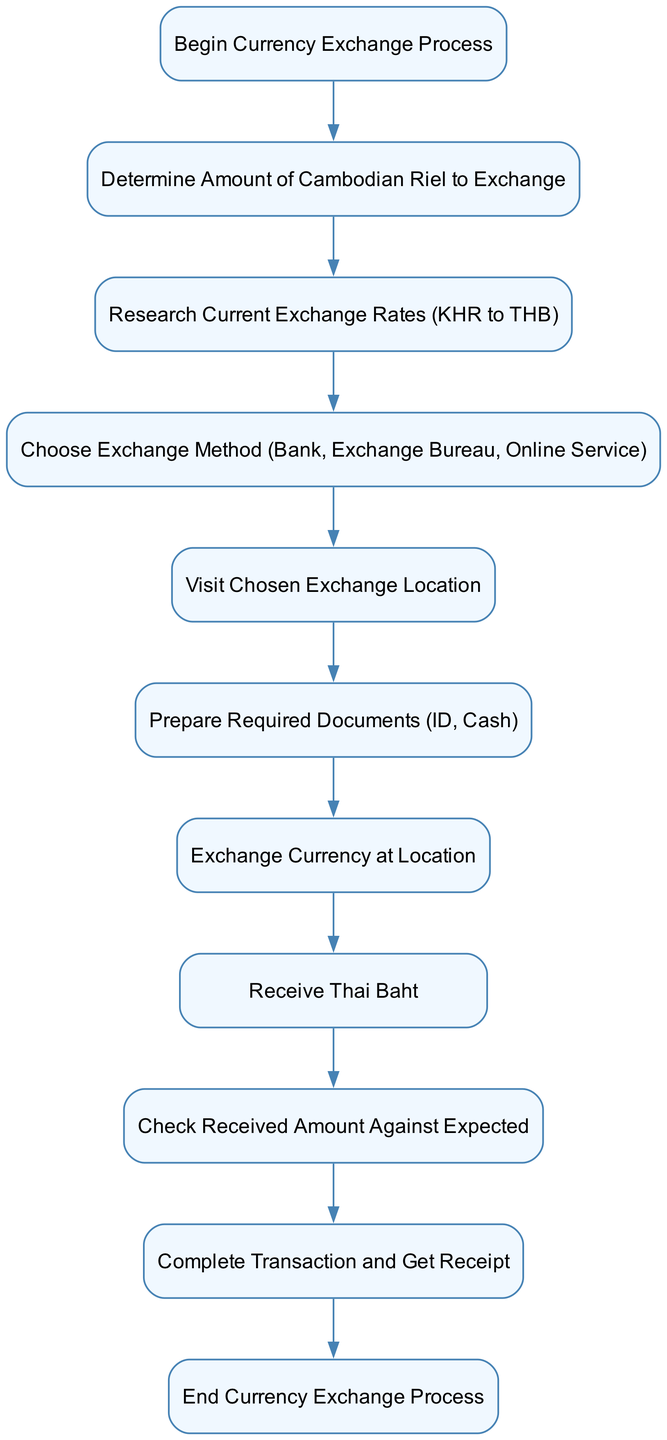What is the first step in the currency exchange process? The first step is labeled as "Begin Currency Exchange Process," which is where the process initiates.
Answer: Begin Currency Exchange Process How many total steps are there in the currency exchange diagram? By counting the distinct nodes in the diagram, there are ten steps listed in the process.
Answer: Ten What documents need to be prepared before exchanging currency? The process specifies that "ID" and "Cash" are the required documents to be prepared before currency exchange.
Answer: ID, Cash What method options are available for exchanging currency? The options available for the exchange method include "Bank," "Exchange Bureau," and "Online Service," as stated in the diagram.
Answer: Bank, Exchange Bureau, Online Service After receiving the Thai Baht, what is the next action required? Following the receipt of Thai Baht, the next action is to "Check Received Amount Against Expected," which ensures that the amount received is correct.
Answer: Check Received Amount Against Expected What does the final step entail? The last step is "End Currency Exchange Process," which indicates the completion of the entire exchange process.
Answer: End Currency Exchange Process In which step do you choose the exchange method? The choice of exchange method occurs at the "Choose Exchange Method (Bank, Exchange Bureau, Online Service]" step. This step follows the research of current exchange rates.
Answer: Choose Exchange Method What is done immediately after visiting the exchange location? Immediately following the visit to the exchange location, you must "Prepare Required Documents (ID, Cash)," which is crucial for the currency exchange process.
Answer: Prepare Required Documents Which step comes directly after determining the amount to exchange? The step that follows determining the amount to exchange is "Research Current Exchange Rates (KHR to THB)," allowing the commuter to establish the current value of their currency.
Answer: Research Current Exchange Rates 